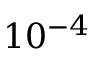<formula> <loc_0><loc_0><loc_500><loc_500>1 0 ^ { - 4 }</formula> 